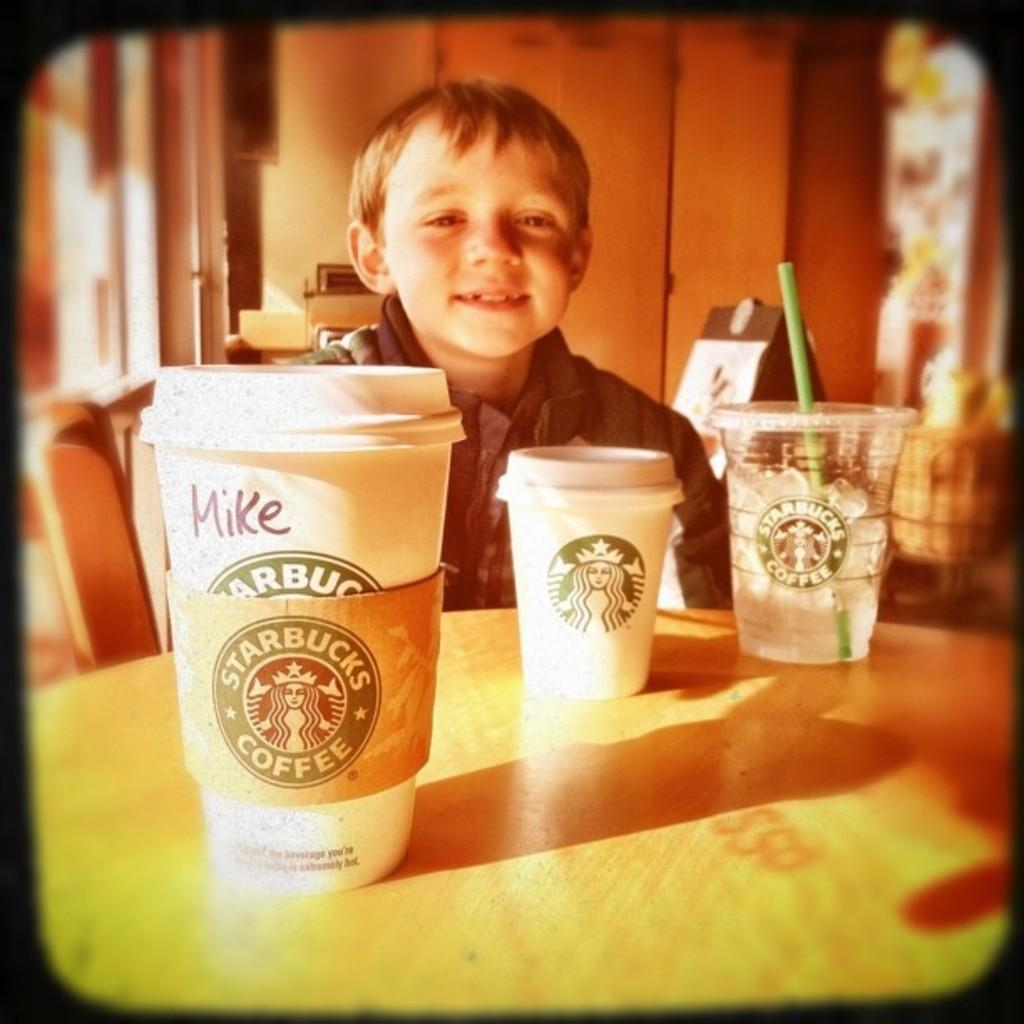<image>
Create a compact narrative representing the image presented. Three Starbucks cups with one labelled to somebody called Mike. 